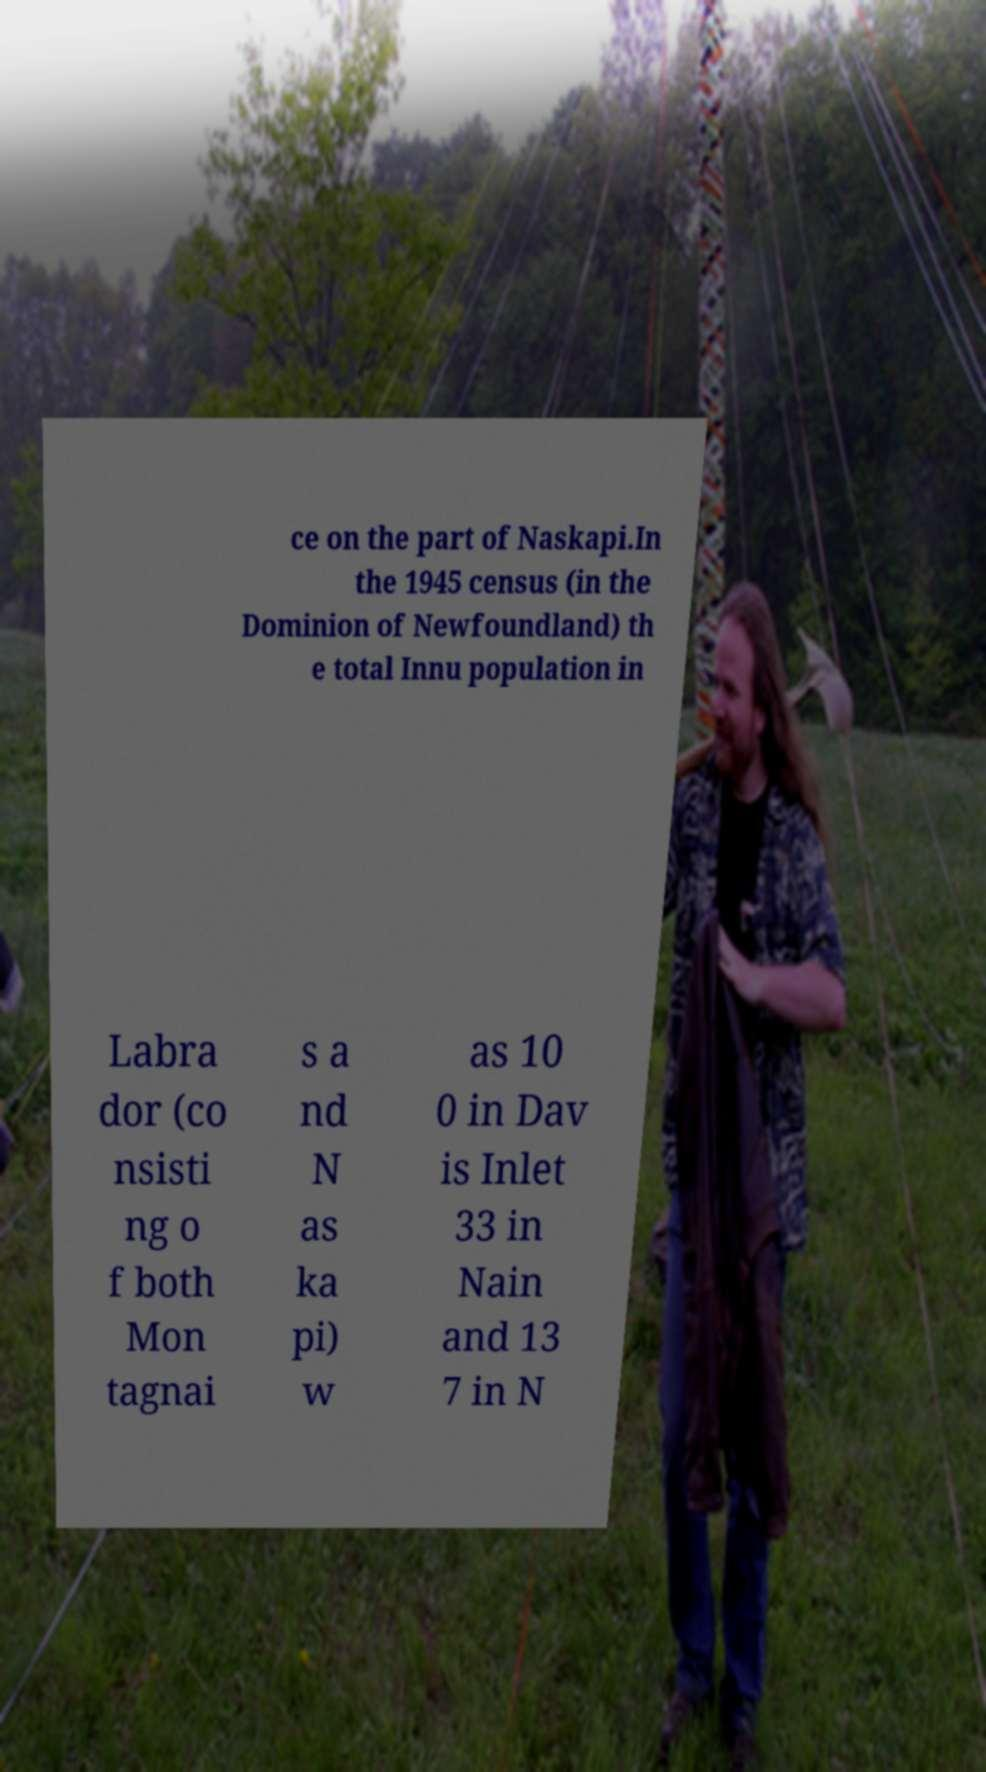For documentation purposes, I need the text within this image transcribed. Could you provide that? ce on the part of Naskapi.In the 1945 census (in the Dominion of Newfoundland) th e total Innu population in Labra dor (co nsisti ng o f both Mon tagnai s a nd N as ka pi) w as 10 0 in Dav is Inlet 33 in Nain and 13 7 in N 